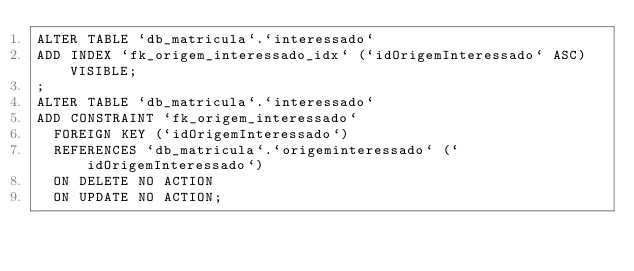<code> <loc_0><loc_0><loc_500><loc_500><_SQL_>ALTER TABLE `db_matricula`.`interessado`
ADD INDEX `fk_origem_interessado_idx` (`idOrigemInteressado` ASC) VISIBLE;
;
ALTER TABLE `db_matricula`.`interessado`
ADD CONSTRAINT `fk_origem_interessado`
  FOREIGN KEY (`idOrigemInteressado`)
  REFERENCES `db_matricula`.`origeminteressado` (`idOrigemInteressado`)
  ON DELETE NO ACTION
  ON UPDATE NO ACTION;
</code> 